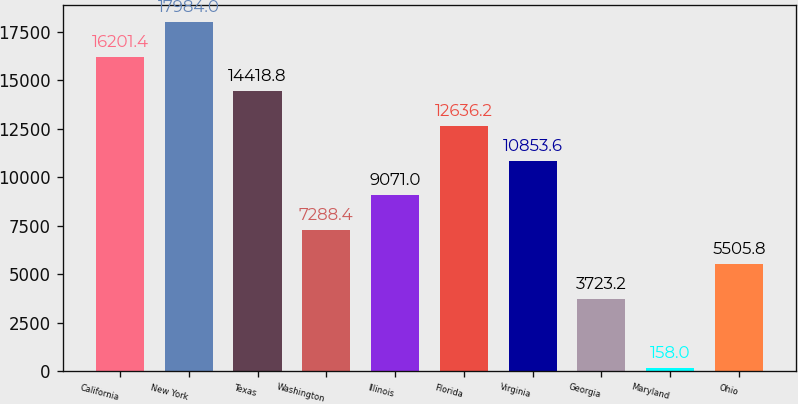Convert chart. <chart><loc_0><loc_0><loc_500><loc_500><bar_chart><fcel>California<fcel>New York<fcel>Texas<fcel>Washington<fcel>Illinois<fcel>Florida<fcel>Virginia<fcel>Georgia<fcel>Maryland<fcel>Ohio<nl><fcel>16201.4<fcel>17984<fcel>14418.8<fcel>7288.4<fcel>9071<fcel>12636.2<fcel>10853.6<fcel>3723.2<fcel>158<fcel>5505.8<nl></chart> 